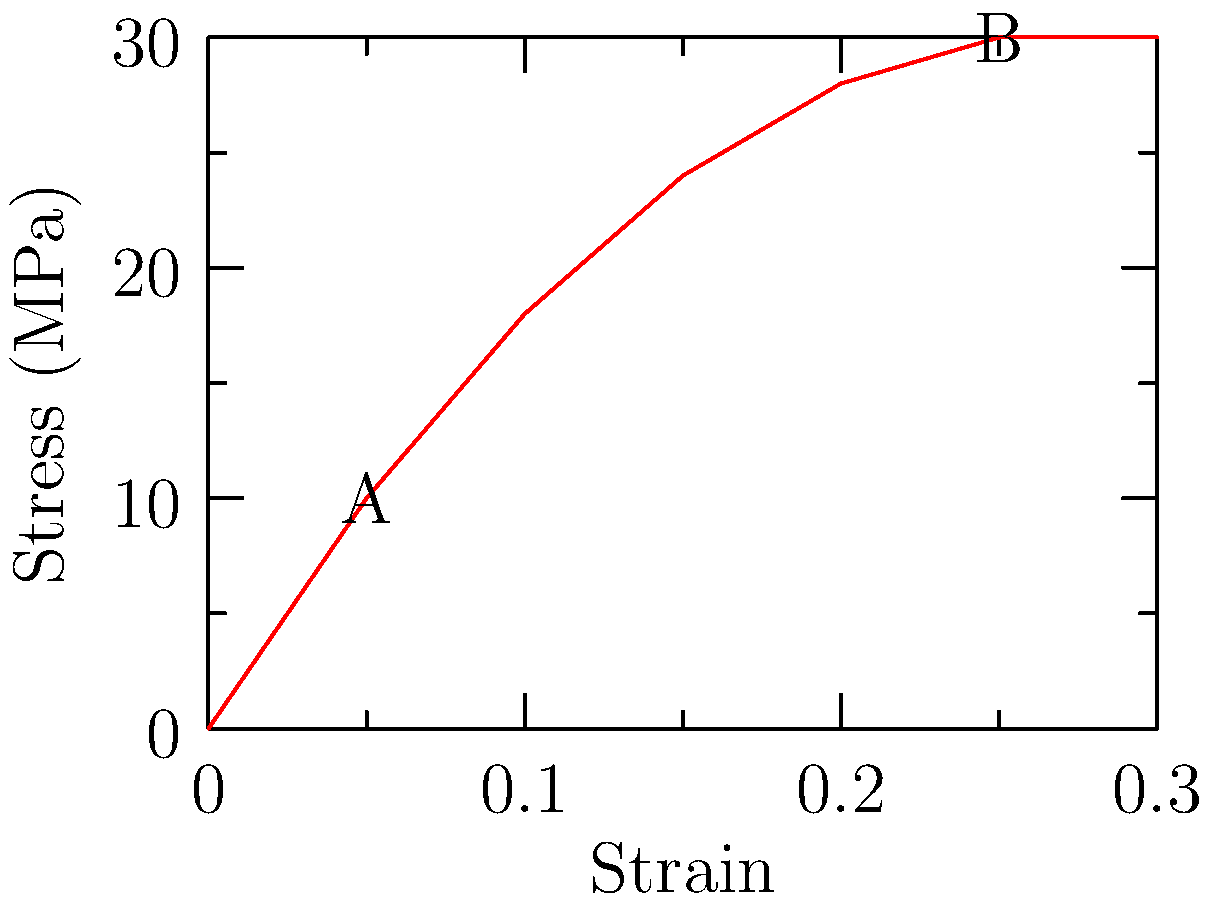As a leather supplier, you're testing a new high-quality hide for its tensile strength. Using the stress-strain curve provided, calculate the Young's modulus of the leather sample between points A and B. Express your answer in MPa. To calculate the Young's modulus, we'll use the formula:

$$ E = \frac{\text{Stress}}{\text{Strain}} = \frac{\Delta \sigma}{\Delta \epsilon} $$

Where:
$E$ is Young's modulus
$\Delta \sigma$ is the change in stress
$\Delta \epsilon$ is the change in strain

Step 1: Identify the coordinates of points A and B
Point A: (0.05, 10 MPa)
Point B: (0.25, 30 MPa)

Step 2: Calculate the change in stress ($\Delta \sigma$)
$\Delta \sigma = 30 \text{ MPa} - 10 \text{ MPa} = 20 \text{ MPa}$

Step 3: Calculate the change in strain ($\Delta \epsilon$)
$\Delta \epsilon = 0.25 - 0.05 = 0.2$

Step 4: Apply the formula for Young's modulus
$$ E = \frac{\Delta \sigma}{\Delta \epsilon} = \frac{20 \text{ MPa}}{0.2} = 100 \text{ MPa} $$

Therefore, the Young's modulus of the leather sample between points A and B is 100 MPa.
Answer: 100 MPa 